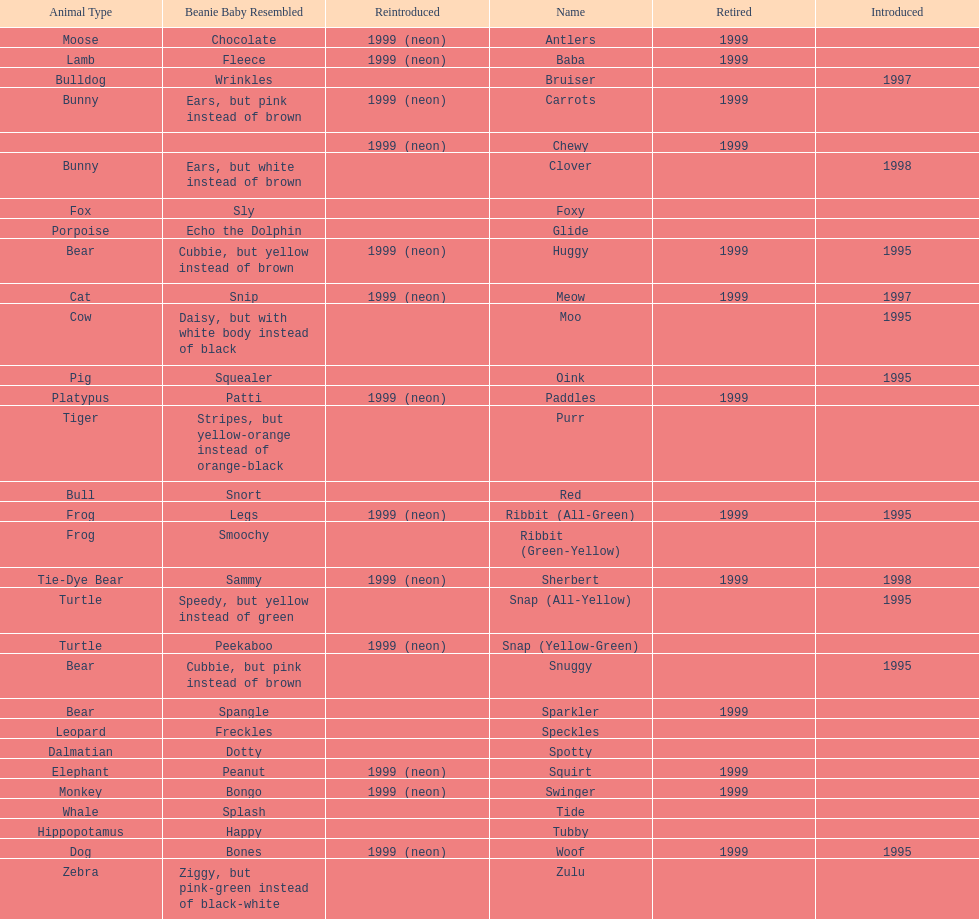What is the appellation of the concluding pillow pal on this graphic? Zulu. 